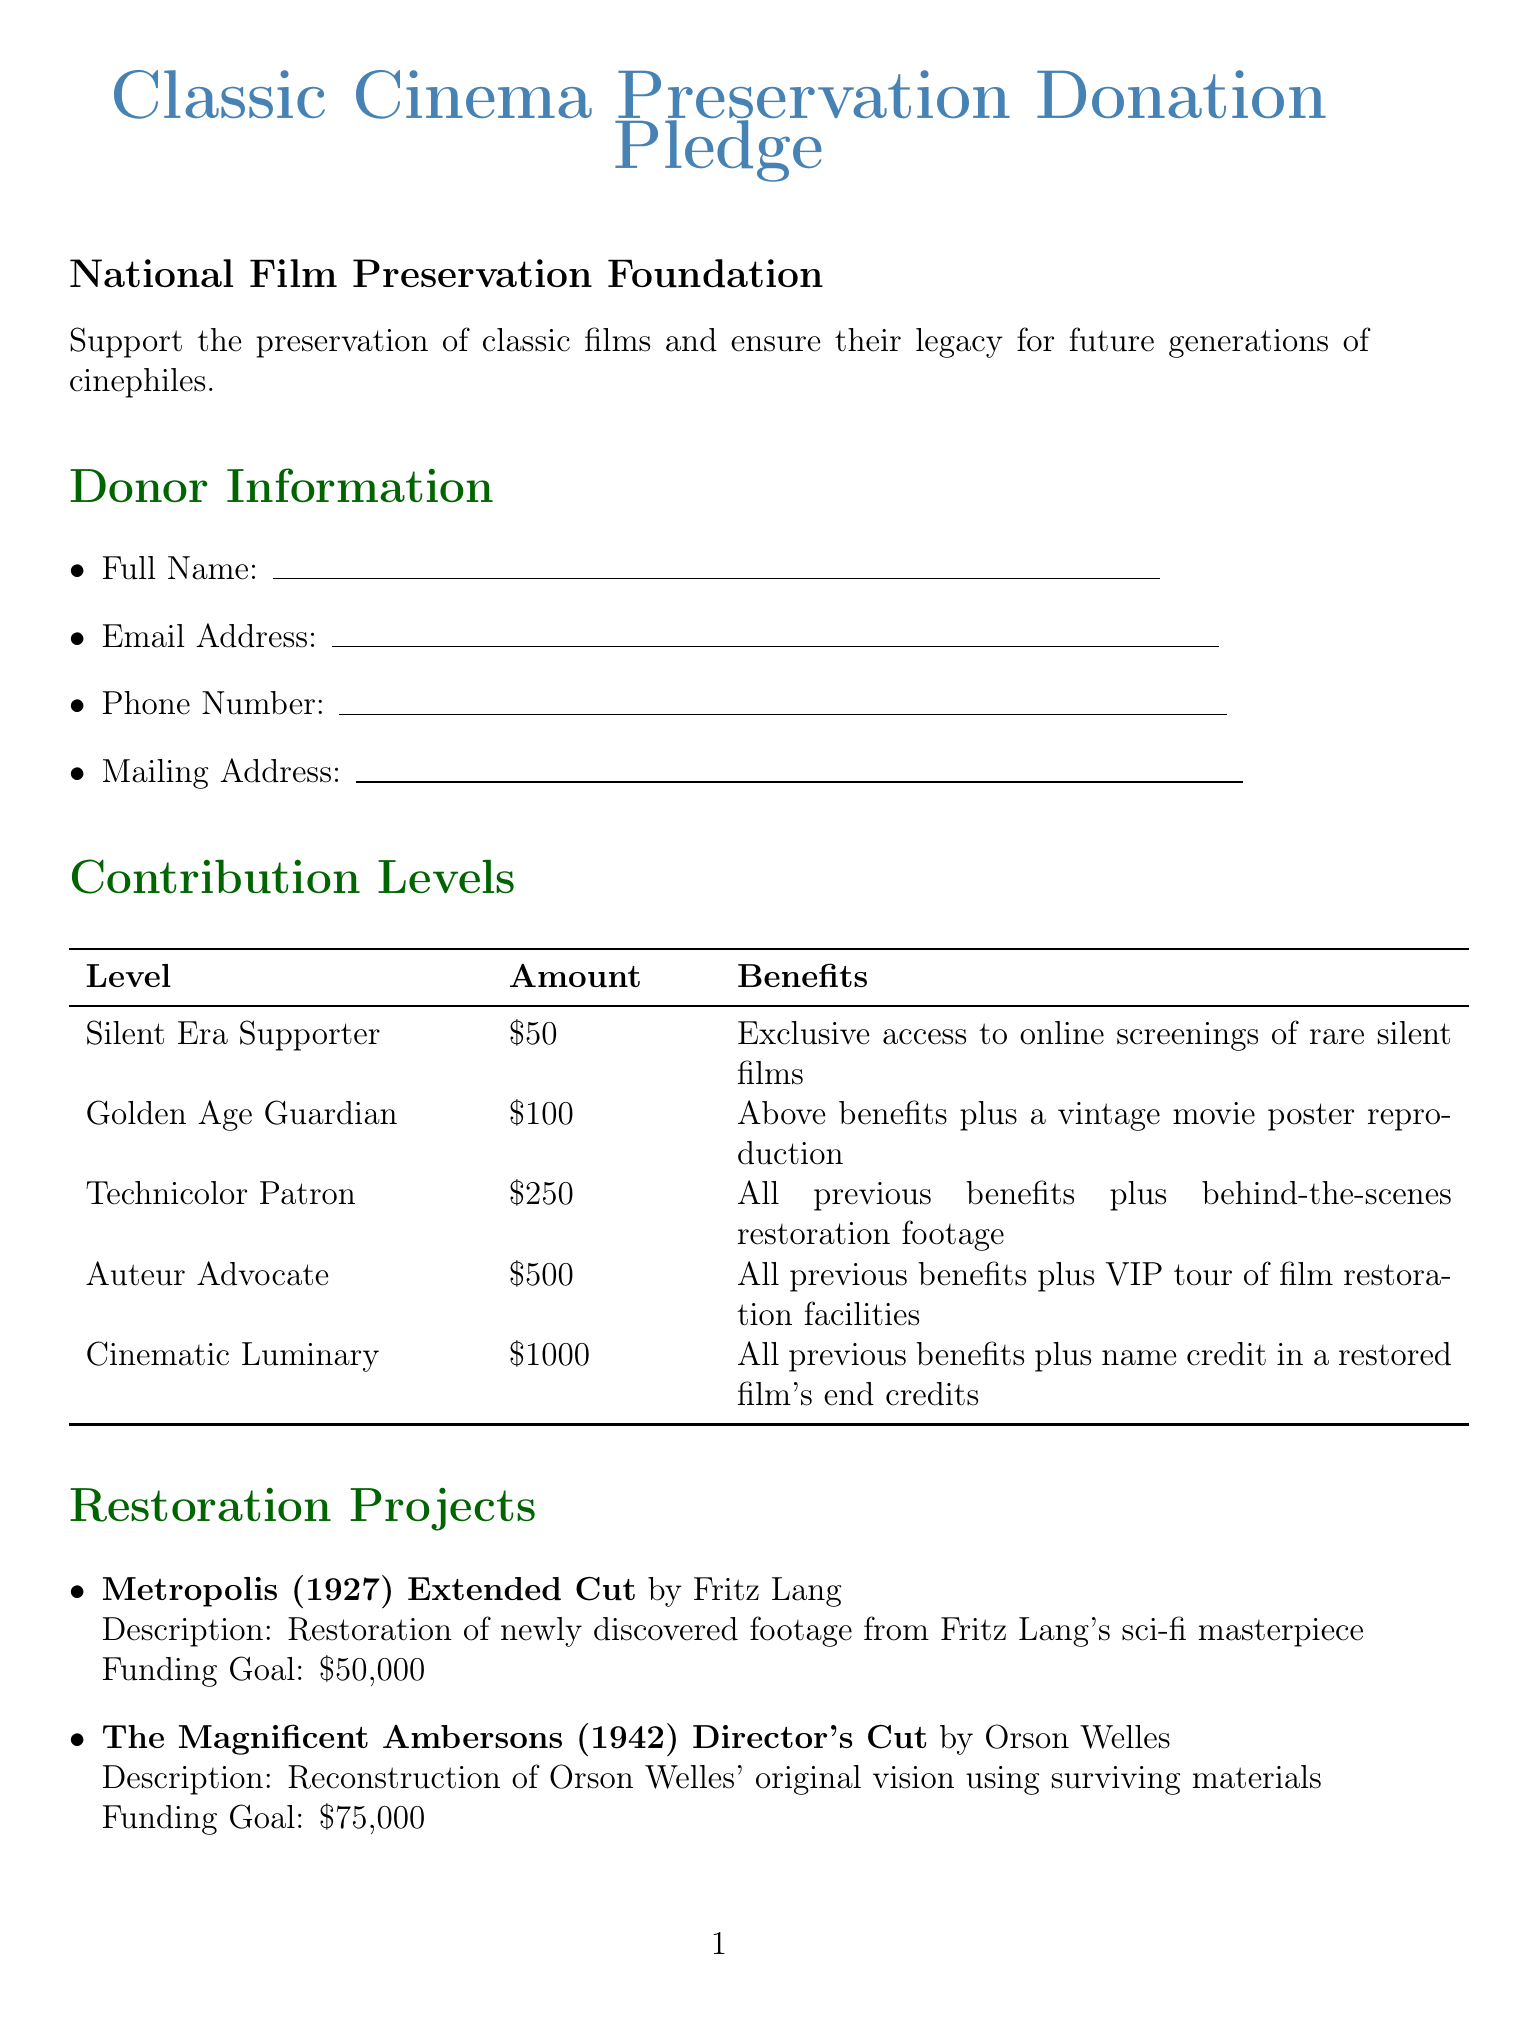what is the title of the form? The title of the form is stated at the beginning of the document.
Answer: Classic Cinema Preservation Donation Pledge who is the organization behind the pledge? The organization's name is provided below the title.
Answer: National Film Preservation Foundation what is the minimum contribution level? The lowest contribution level is listed in the contribution levels section.
Answer: 50 what is the funding goal for "A Star Is Born (1954) 4K Restoration"? The funding goal for this restoration project is detailed in the projects section.
Answer: 100000 which project involves the director Orson Welles? The project associated with Orson Welles is mentioned in the restoration projects section.
Answer: The Magnificent Ambersons (1942) Director's Cut what is one of the payment options available? The document lists several payment options in a separate section.
Answer: Credit Card what benefit do you receive as a "Technicolor Patron"? The benefits associated with this contribution level are outlined under contribution levels.
Answer: All previous benefits plus behind-the-scenes restoration footage how can you indicate recognition preferences? The recognition preferences are listed as checkboxes in the document.
Answer: List my name in the annual donor report what kind of restoration is being done for "Lost Horizon"? The description of this project specifies the type of restoration.
Answer: Audio Restoration 